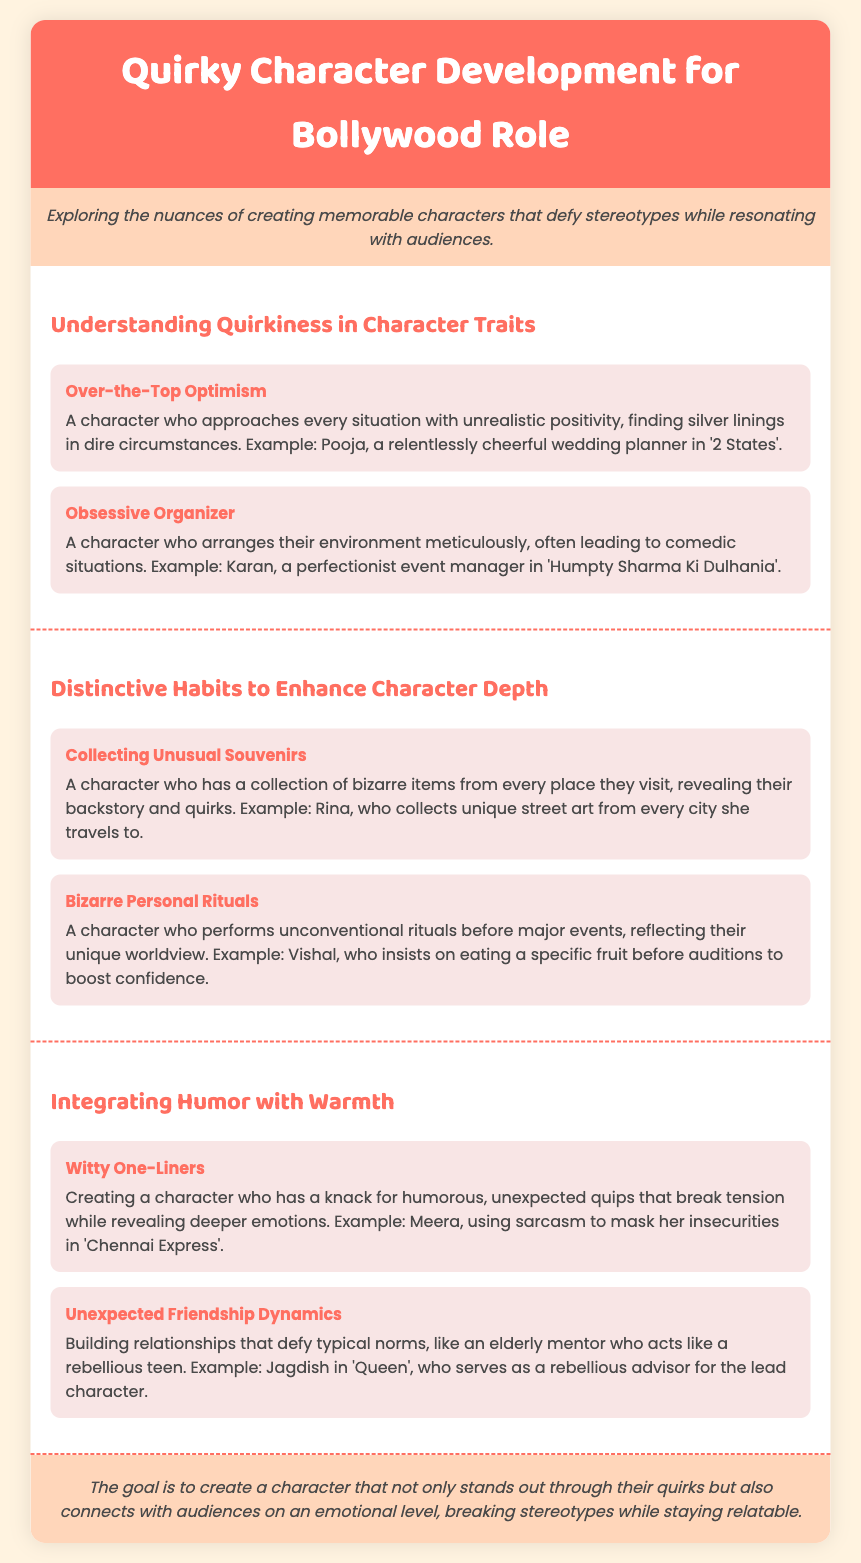What is the title of the document? The title of the document is indicated in the header, which is "Quirky Character Development for Bollywood Role."
Answer: Quirky Character Development for Bollywood Role What is the color of the header? The header is a specific color described in the document, which is "#FF6F61."
Answer: #FF6F61 Who is given as an example of "Over-the-Top Optimism"? The document provides an example character to illustrate this trait, which is "Pooja."
Answer: Pooja What is one distinctive habit mentioned in the document? The document lists several habits, one of which is "Collecting Unusual Souvenirs."
Answer: Collecting Unusual Souvenirs What does Meera use to mask her insecurities? The document illustrates how Meera employs humor, specifically through "sarcasm."
Answer: sarcasm How does the document suggest integrating humor with warmth? The document outlines ideas to combine humor and warmth, such as using "Witty One-Liners."
Answer: Witty One-Liners What type of character trait is described as "Obsessive Organizer"? The character trait characterized in this way is a tendency towards organization, described as "Obsessive Organizer."
Answer: Obsessive Organizer What is the main goal for character development according to the conclusion? The conclusion summarizes the primary aim of character creation as connecting on an emotional level, stated as "create a character that... connects with audiences."
Answer: connects with audiences What was Vishal's unusual personal ritual before auditions? The document explains that Vishal performs a specific act related to food, which is "eating a specific fruit."
Answer: eating a specific fruit 